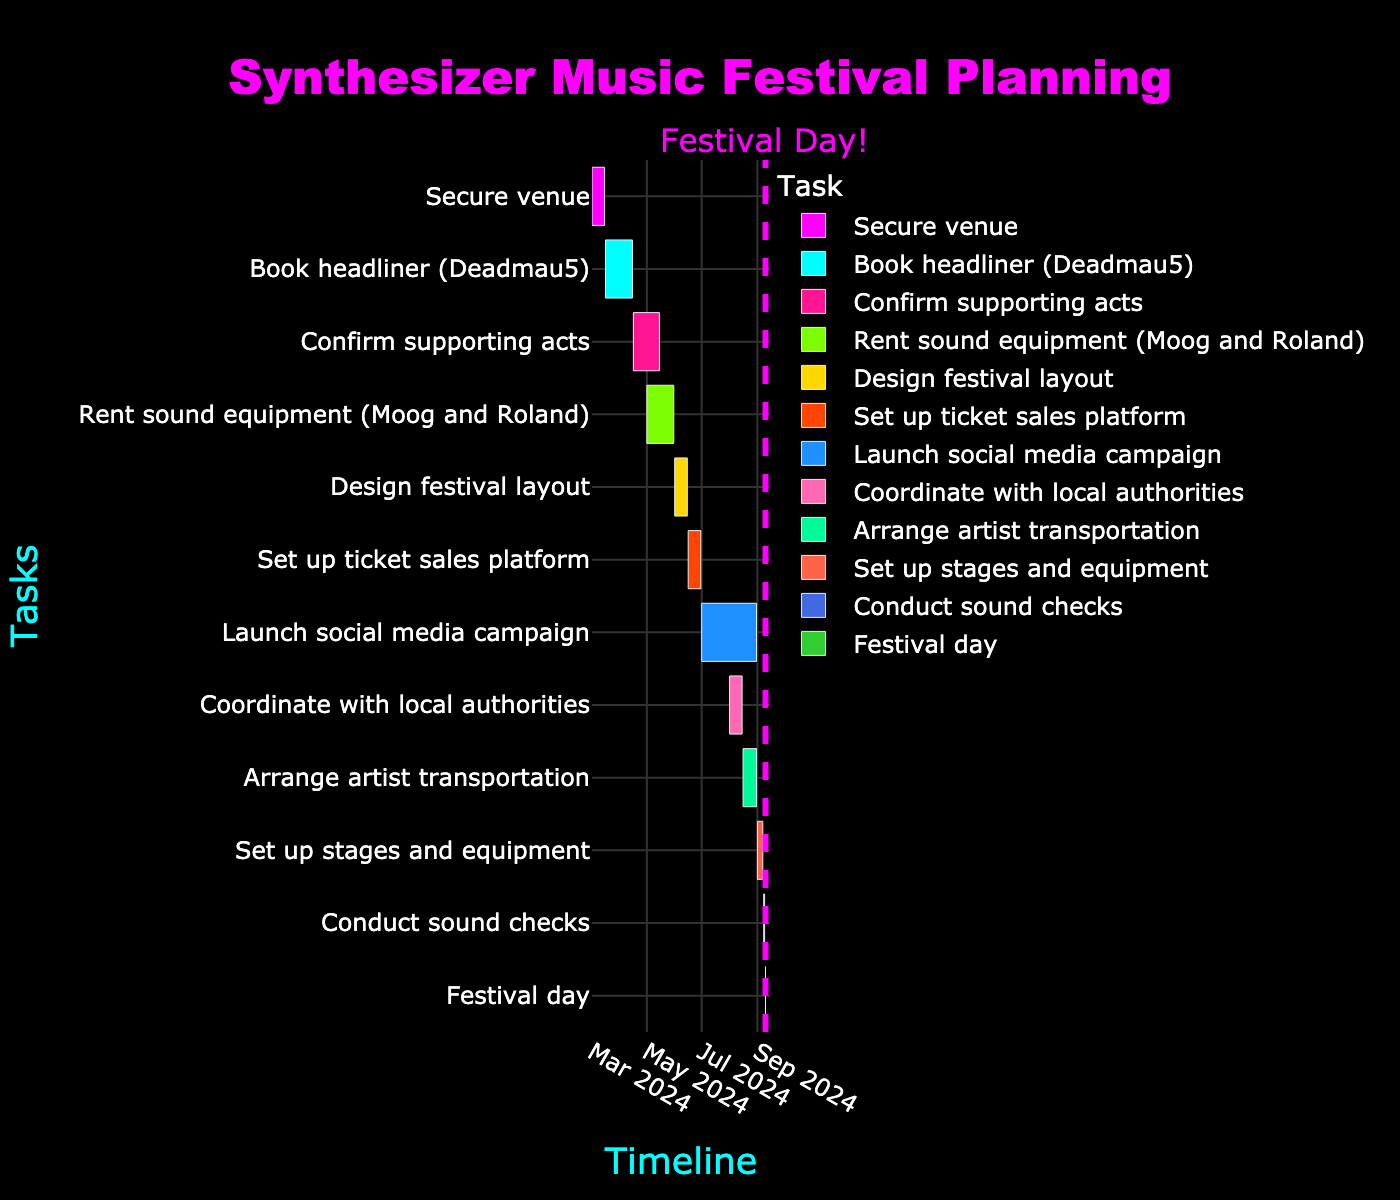Which task has the shortest duration? To find the task with the shortest duration, look at the "Duration" column in the Gantt chart to see which one has the lowest value. The "Festival day" has a duration of 1 day, which is the shortest.
Answer: Festival day What is the duration of the social media campaign? Locate the "Launch social media campaign" in the Gantt chart, then look at its duration, which is given as 62 days.
Answer: 62 days Which two tasks overlap in the month of August? Review the timeline bars for tasks occurring in August. "Launch social media campaign" (July 1 to August 31) overlaps with "Coordinate with local authorities" (August 1 to August 15) and "Arrange artist transportation" (August 16 to August 31).
Answer: Launch social media campaign, Coordinate with local authorities, Arrange artist transportation What is the duration of the project from the first to the last task? Calculate the time span from the start of "Secure venue" (March 1, 2024) to the end of "Festival day" (September 10, 2024). This is given as March 1 to September 10, which is 194 days.
Answer: 194 days Which task takes place right before the festival day? Check which task ends right before the "Festival day" on September 10. "Conduct sound checks" on September 8-9, 2024 is the task immediately before.
Answer: Conduct sound checks How many tasks are scheduled to finish in the month of May? Identify tasks whose "End Date" falls within the month of May. "Confirm supporting acts" and "Rent sound equipment" both finish in May.
Answer: 2 tasks By how many days does the launch of the social media campaign overlap with the coordination with local authorities? The "Launch social media campaign" runs from July 1 to August 31, and "Coordinate with local authorities" starts on August 1 and ends on August 15. The overlap period is from August 1 to August 15, which is 15 days.
Answer: 15 days Which task uses the color #FF6347 (tomato color)? Identify the task associated with the color #FF6347 (tomato color) from the Gantt chart. "Set up stages and equipment" is represented with this color.
Answer: Set up stages and equipment What logical sequence of tasks leads up to the "Festival day"? Inspect the timeline sequence of tasks before "Festival day". They are: "Set up stages and equipment" (September 1-7), "Conduct sound checks" (September 8-9), and finally "Festival day" (September 10).
Answer: Set up stages and equipment → Conduct sound checks → Festival day What is the longest task and how many days does it last? Check the durations to see which task has the longest period. "Launch social media campaign" is the longest one with 62 days.
Answer: Launch social media campaign, 62 days 